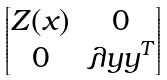Convert formula to latex. <formula><loc_0><loc_0><loc_500><loc_500>\begin{bmatrix} Z ( x ) & 0 \\ 0 & \lambda y y ^ { T } \end{bmatrix}</formula> 